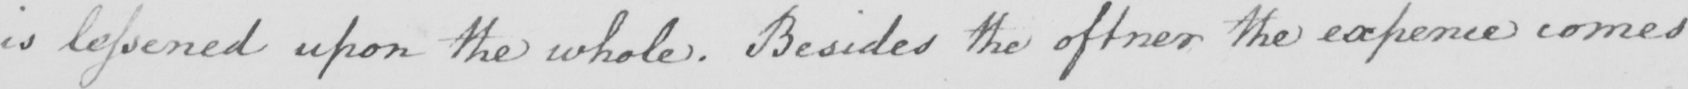Can you tell me what this handwritten text says? is lessened upon the whole . Besides the oftner the experience comes 